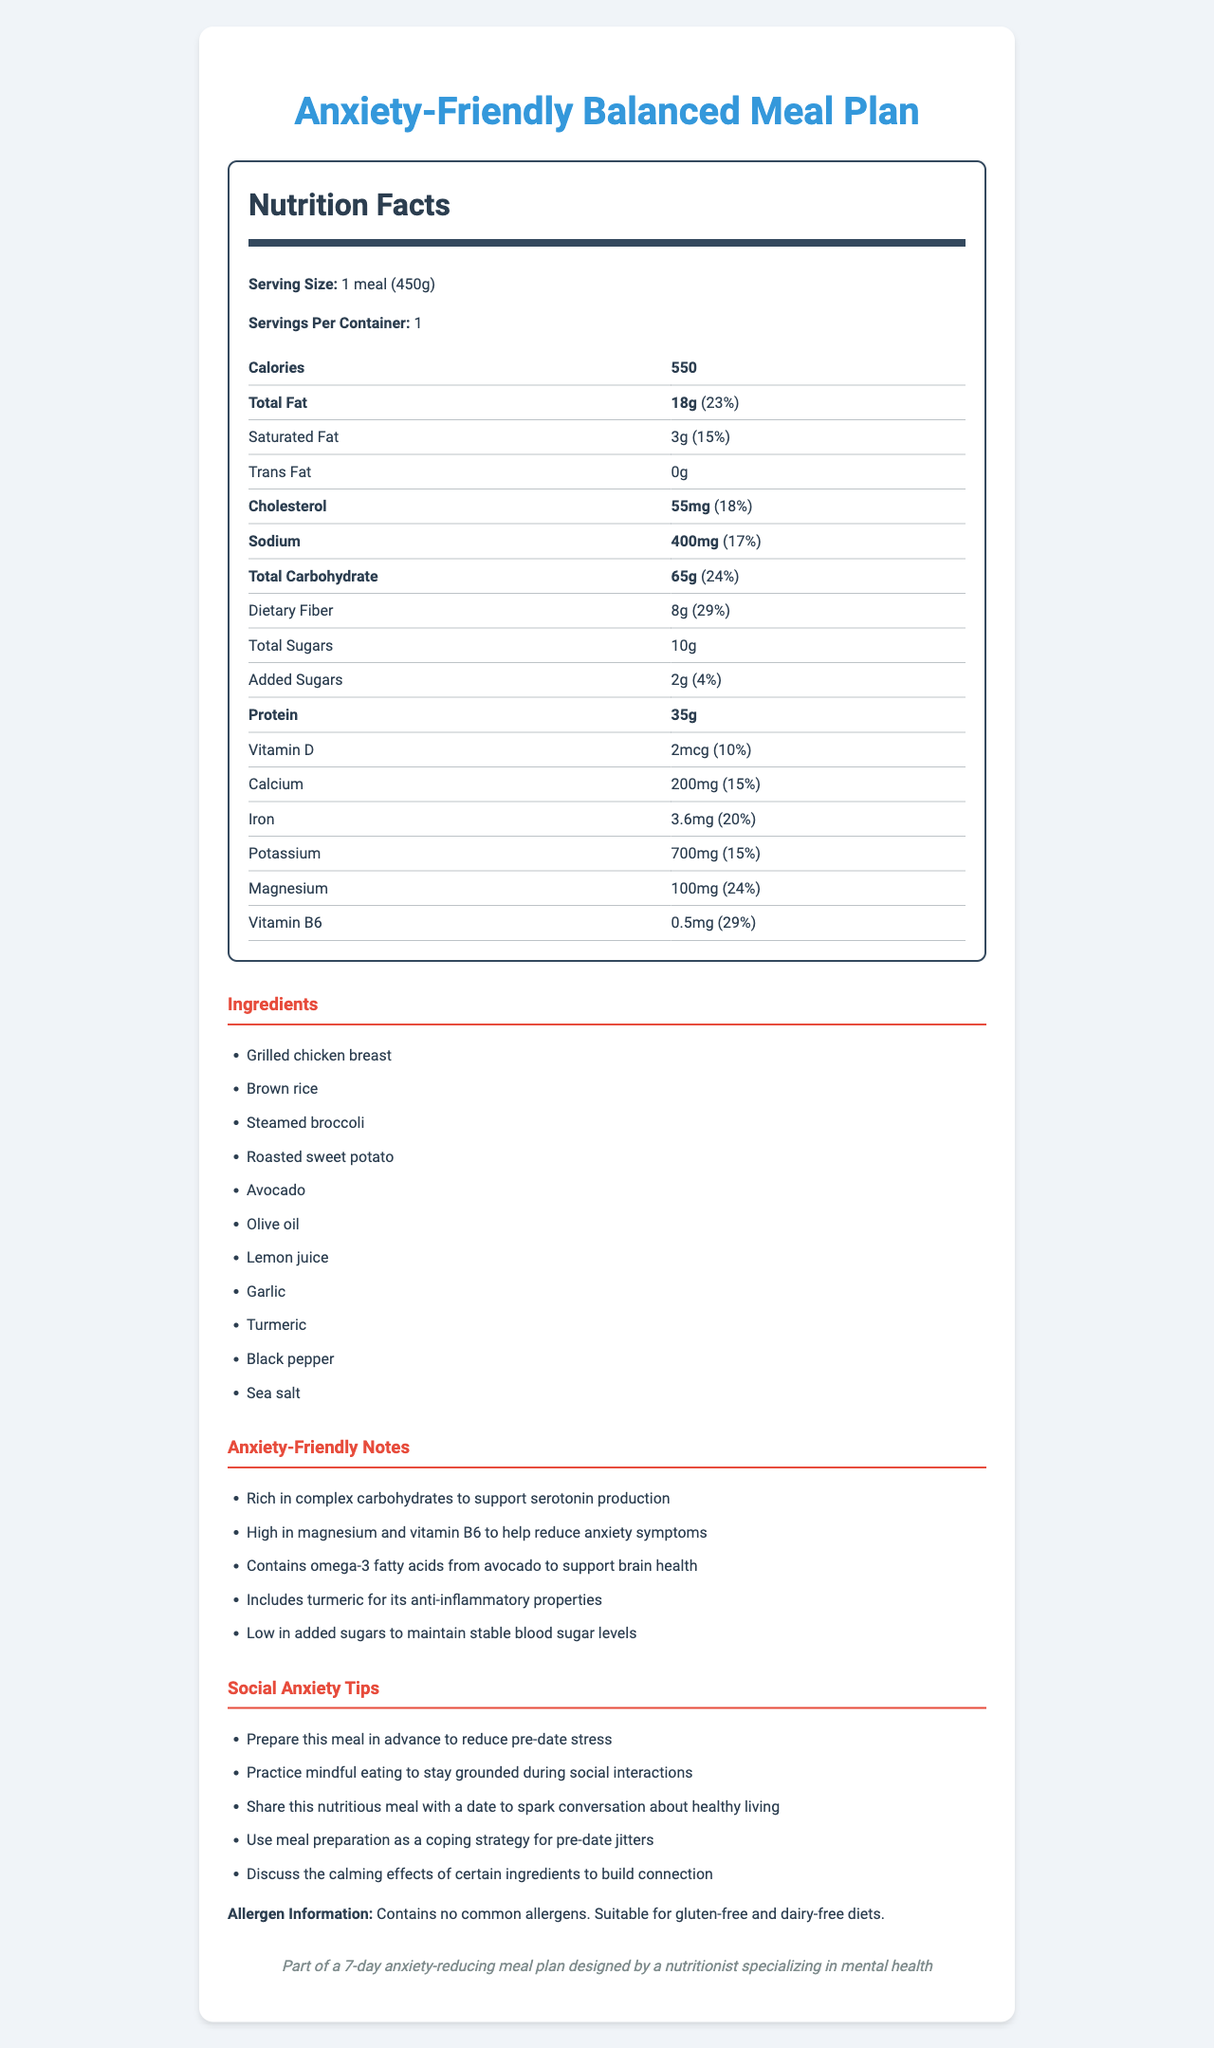what is the serving size for this meal? The serving size is clearly listed as "1 meal (450g)" in the document.
Answer: 1 meal (450g) how many calories are there per serving? The calories per serving are stated as "550" in the nutrition facts.
Answer: 550 what is the total fat content in this meal? The total fat content is listed as "18g" in the document.
Answer: 18g what percentage of the daily value of sodium does this meal provide? The daily value percentage for sodium is "17%" as indicated in the nutrition facts.
Answer: 17% what is the amount of cholesterol in this meal? The nutrition facts state the amount of cholesterol as "55mg".
Answer: 55mg which ingredient provides omega-3 fatty acids? The anxiety-friendly notes mention that avocado includes omega-3 fatty acids.
Answer: Avocado how many grams of dietary fiber does this meal have? The dietary fiber content is listed as "8g" in the nutrition facts.
Answer: 8g which of the following is NOT an ingredient in the meal? A. Brown rice B. Garlic C. Chicken thighs D. Olive oil The listed ingredients include "Grilled chicken breast" but no mention of "Chicken thighs".
Answer: C. Chicken thighs how can meal preparation assist someone with social anxiety before a date? A. It helps save time. B. It serves as a coping strategy. C. It increases calorie intake. D. It makes you feel full longer. One of the social anxiety tips suggests using meal preparation as a coping strategy for pre-date jitters.
Answer: B. It serves as a coping strategy. does this meal contain any common allergens? The allergen information specifies that it contains no common allergens.
Answer: No summarize the main idea of this document. The document outlines the serving size and nutritional information for the meal, highlights ingredients, explains how the meal supports anxiety reduction, offers social anxiety coping tips, and states allergen information.
Answer: This document provides the nutrition facts for an anxiety-friendly balanced meal plan designed for individuals with social anxiety, including detailed nutritional content, ingredients, anxiety-friendly benefits, and social anxiety tips. does this meal plan include a recipe? The document lists the ingredients but does not provide any specific recipe or cooking instructions.
Answer: Cannot be determined 